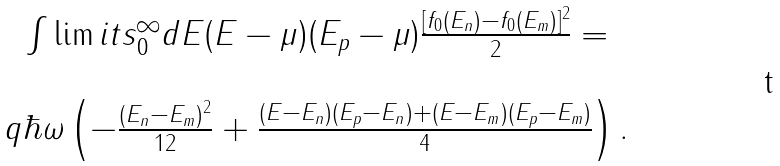<formula> <loc_0><loc_0><loc_500><loc_500>\begin{array} { c } \int \lim i t s _ { 0 } ^ { \infty } d E ( E - \mu ) ( E _ { p } - \mu ) \frac { [ f _ { 0 } ( E _ { n } ) - f _ { 0 } ( E _ { m } ) ] ^ { 2 } } { 2 } = \\ \ \\ q \hbar { \omega } \left ( - \frac { ( E _ { n } - E _ { m } ) ^ { 2 } } { 1 2 } + \frac { ( E - E _ { n } ) ( E _ { p } - E _ { n } ) + ( E - E _ { m } ) ( E _ { p } - E _ { m } ) } { 4 } \right ) . \end{array}</formula> 